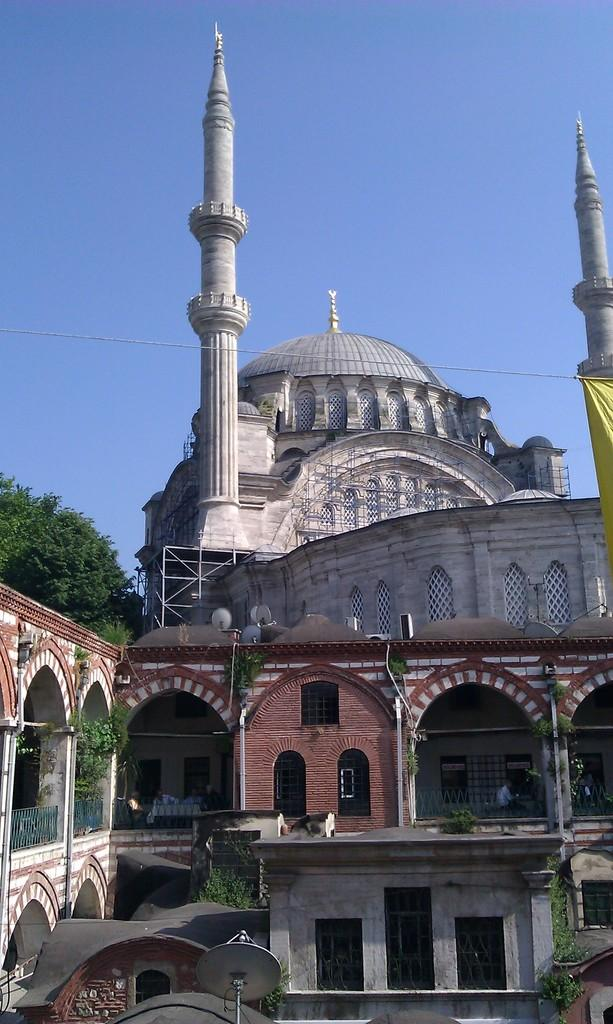What types of structures can be seen in the image? There are buildings in the image. What other elements are present in the image besides buildings? There are plants, persons, a railing, an antenna, other objects, trees, and the sky visible in the background. Can you describe the vegetation in the image? There are plants and trees in the image. What is the purpose of the railing in the image? The railing's purpose is not explicitly stated, but it may be for safety or to provide a barrier. What can be seen in the background of the image? There are trees and the sky visible in the background of the image. What type of corn is growing on the antenna in the image? There is no corn present in the image, and the antenna is not depicted as having any plants growing on it. What beam of light can be seen coming from the railing in the image? There is no beam of light present in the image; the railing is a stationary object. 